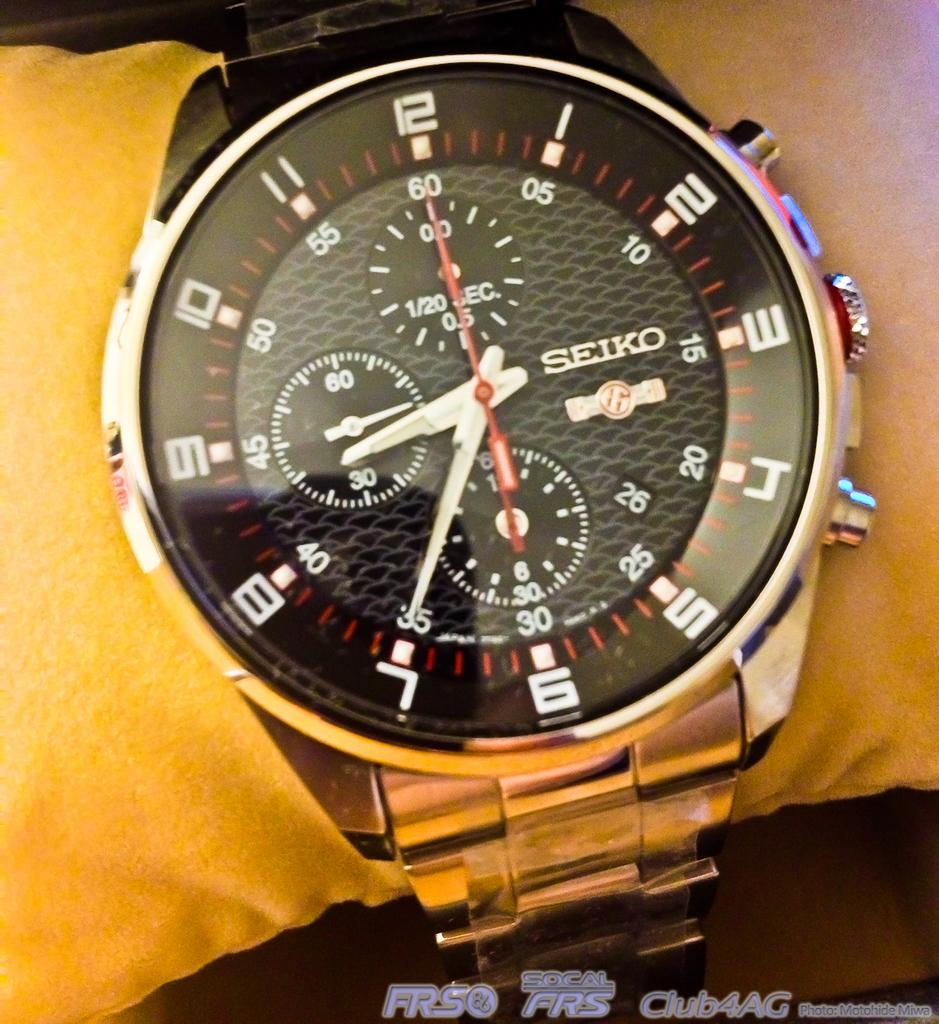<image>
Offer a succinct explanation of the picture presented. A Seiko watch has a silver link band. 